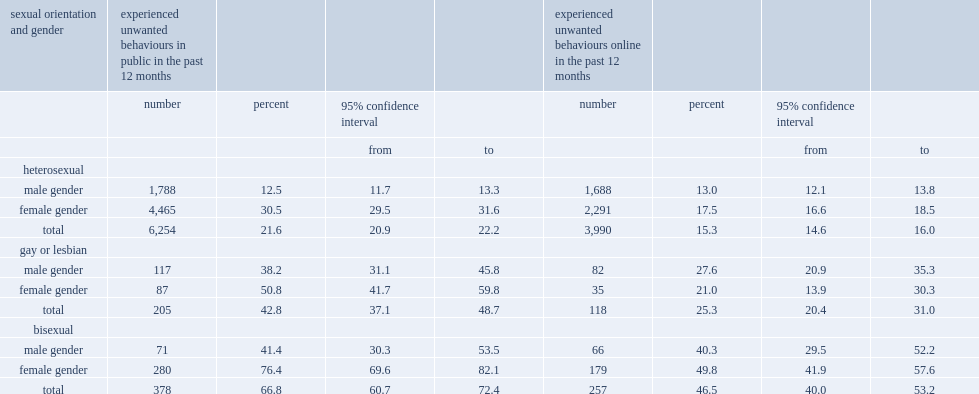How many percent of bisexual women have reported that they had experienced an inappropriate behaviour in public? 76.4. Which group of sexual minorities has the highest proportion of reporting that they had experienced an inappropriate behaviour in public? Female gender. How many percent of all bisexual men have experienced unwanted behaviours online in the past 12 months. 40.3. 